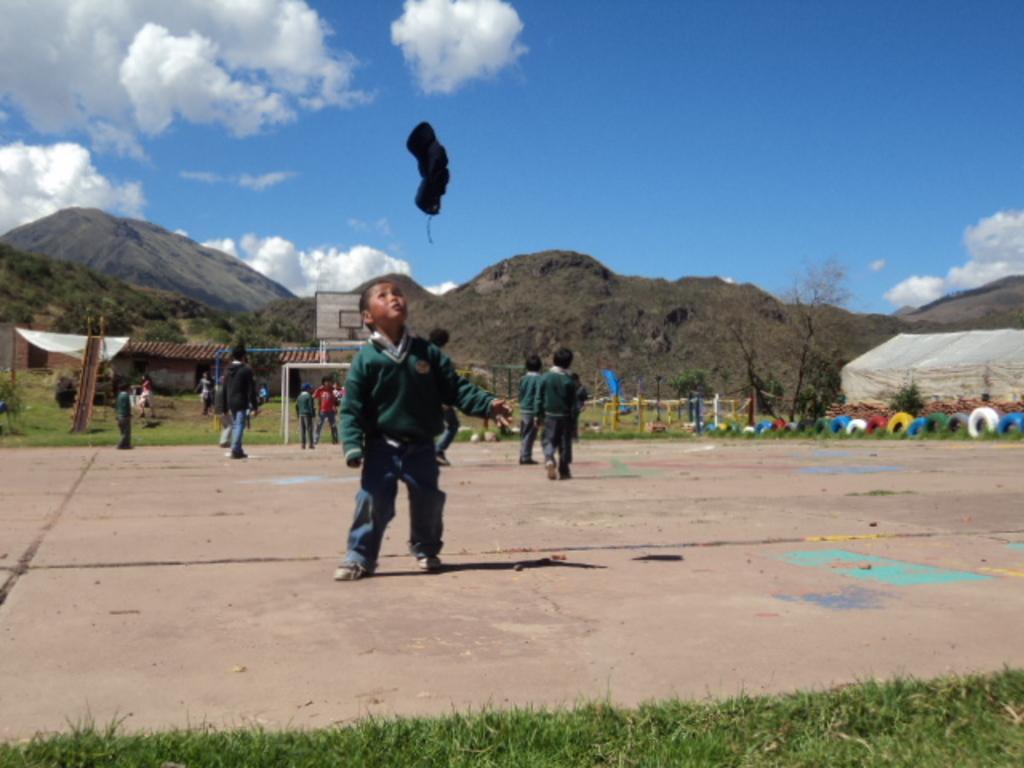In one or two sentences, can you explain what this image depicts? In this image there are a group of children standing, and in the air there is some object. At the bottom there is walkway and grass, and on the right side there are some tents and tires and fence and some houses are there in the background and also some mountains. At the top there is sky. 